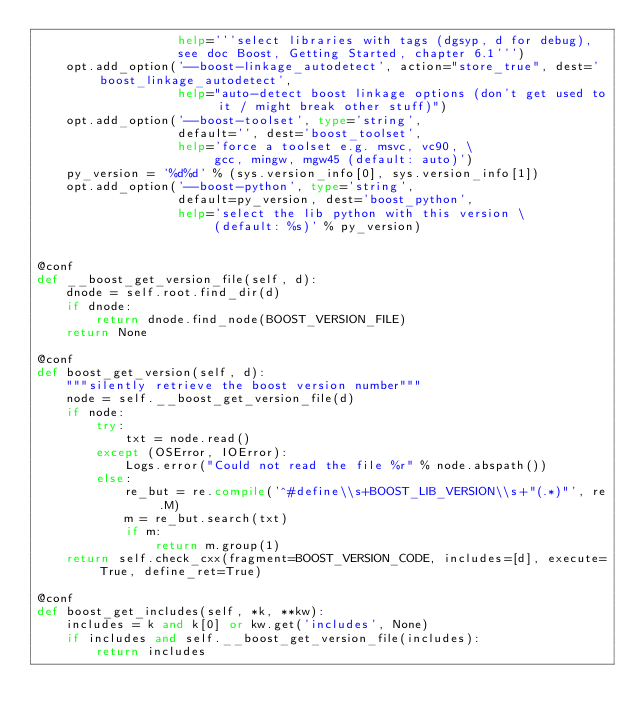Convert code to text. <code><loc_0><loc_0><loc_500><loc_500><_Python_>				   help='''select libraries with tags (dgsyp, d for debug),
				   see doc Boost, Getting Started, chapter 6.1''')
	opt.add_option('--boost-linkage_autodetect', action="store_true", dest='boost_linkage_autodetect',
				   help="auto-detect boost linkage options (don't get used to it / might break other stuff)")
	opt.add_option('--boost-toolset', type='string',
				   default='', dest='boost_toolset',
				   help='force a toolset e.g. msvc, vc90, \
						gcc, mingw, mgw45 (default: auto)')
	py_version = '%d%d' % (sys.version_info[0], sys.version_info[1])
	opt.add_option('--boost-python', type='string',
				   default=py_version, dest='boost_python',
				   help='select the lib python with this version \
						(default: %s)' % py_version)


@conf
def __boost_get_version_file(self, d):
	dnode = self.root.find_dir(d)
	if dnode:
		return dnode.find_node(BOOST_VERSION_FILE)
	return None

@conf
def boost_get_version(self, d):
	"""silently retrieve the boost version number"""
	node = self.__boost_get_version_file(d)
	if node:
		try:
			txt = node.read()
		except (OSError, IOError):
			Logs.error("Could not read the file %r" % node.abspath())
		else:
			re_but = re.compile('^#define\\s+BOOST_LIB_VERSION\\s+"(.*)"', re.M)
			m = re_but.search(txt)
			if m:
				return m.group(1)
	return self.check_cxx(fragment=BOOST_VERSION_CODE, includes=[d], execute=True, define_ret=True)

@conf
def boost_get_includes(self, *k, **kw):
	includes = k and k[0] or kw.get('includes', None)
	if includes and self.__boost_get_version_file(includes):
		return includes</code> 